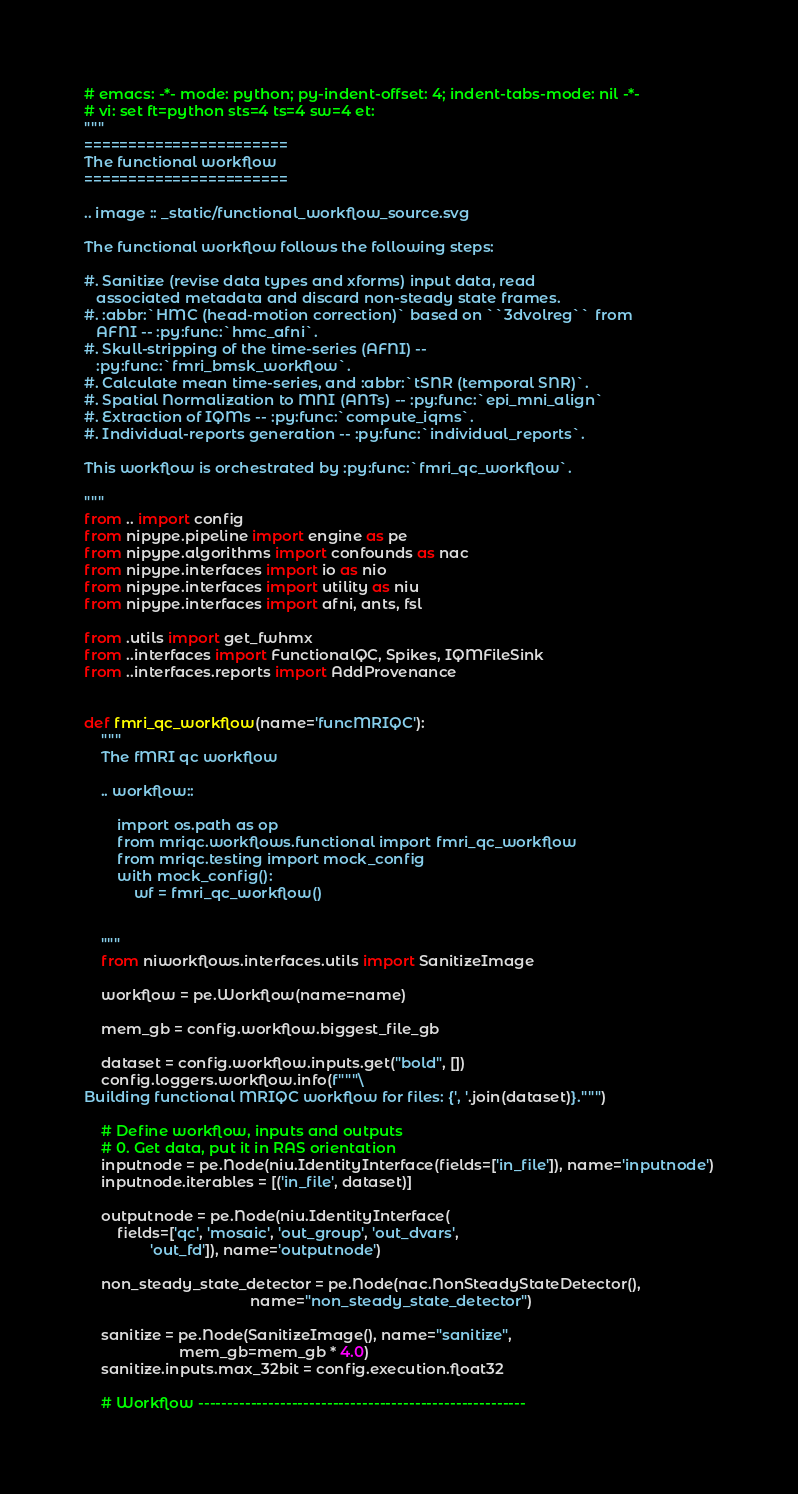<code> <loc_0><loc_0><loc_500><loc_500><_Python_># emacs: -*- mode: python; py-indent-offset: 4; indent-tabs-mode: nil -*-
# vi: set ft=python sts=4 ts=4 sw=4 et:
"""
=======================
The functional workflow
=======================

.. image :: _static/functional_workflow_source.svg

The functional workflow follows the following steps:

#. Sanitize (revise data types and xforms) input data, read
   associated metadata and discard non-steady state frames.
#. :abbr:`HMC (head-motion correction)` based on ``3dvolreg`` from
   AFNI -- :py:func:`hmc_afni`.
#. Skull-stripping of the time-series (AFNI) --
   :py:func:`fmri_bmsk_workflow`.
#. Calculate mean time-series, and :abbr:`tSNR (temporal SNR)`.
#. Spatial Normalization to MNI (ANTs) -- :py:func:`epi_mni_align`
#. Extraction of IQMs -- :py:func:`compute_iqms`.
#. Individual-reports generation -- :py:func:`individual_reports`.

This workflow is orchestrated by :py:func:`fmri_qc_workflow`.

"""
from .. import config
from nipype.pipeline import engine as pe
from nipype.algorithms import confounds as nac
from nipype.interfaces import io as nio
from nipype.interfaces import utility as niu
from nipype.interfaces import afni, ants, fsl

from .utils import get_fwhmx
from ..interfaces import FunctionalQC, Spikes, IQMFileSink
from ..interfaces.reports import AddProvenance


def fmri_qc_workflow(name='funcMRIQC'):
    """
    The fMRI qc workflow

    .. workflow::

        import os.path as op
        from mriqc.workflows.functional import fmri_qc_workflow
        from mriqc.testing import mock_config
        with mock_config():
            wf = fmri_qc_workflow()


    """
    from niworkflows.interfaces.utils import SanitizeImage

    workflow = pe.Workflow(name=name)

    mem_gb = config.workflow.biggest_file_gb

    dataset = config.workflow.inputs.get("bold", [])
    config.loggers.workflow.info(f"""\
Building functional MRIQC workflow for files: {', '.join(dataset)}.""")

    # Define workflow, inputs and outputs
    # 0. Get data, put it in RAS orientation
    inputnode = pe.Node(niu.IdentityInterface(fields=['in_file']), name='inputnode')
    inputnode.iterables = [('in_file', dataset)]

    outputnode = pe.Node(niu.IdentityInterface(
        fields=['qc', 'mosaic', 'out_group', 'out_dvars',
                'out_fd']), name='outputnode')

    non_steady_state_detector = pe.Node(nac.NonSteadyStateDetector(),
                                        name="non_steady_state_detector")

    sanitize = pe.Node(SanitizeImage(), name="sanitize",
                       mem_gb=mem_gb * 4.0)
    sanitize.inputs.max_32bit = config.execution.float32

    # Workflow --------------------------------------------------------
</code> 